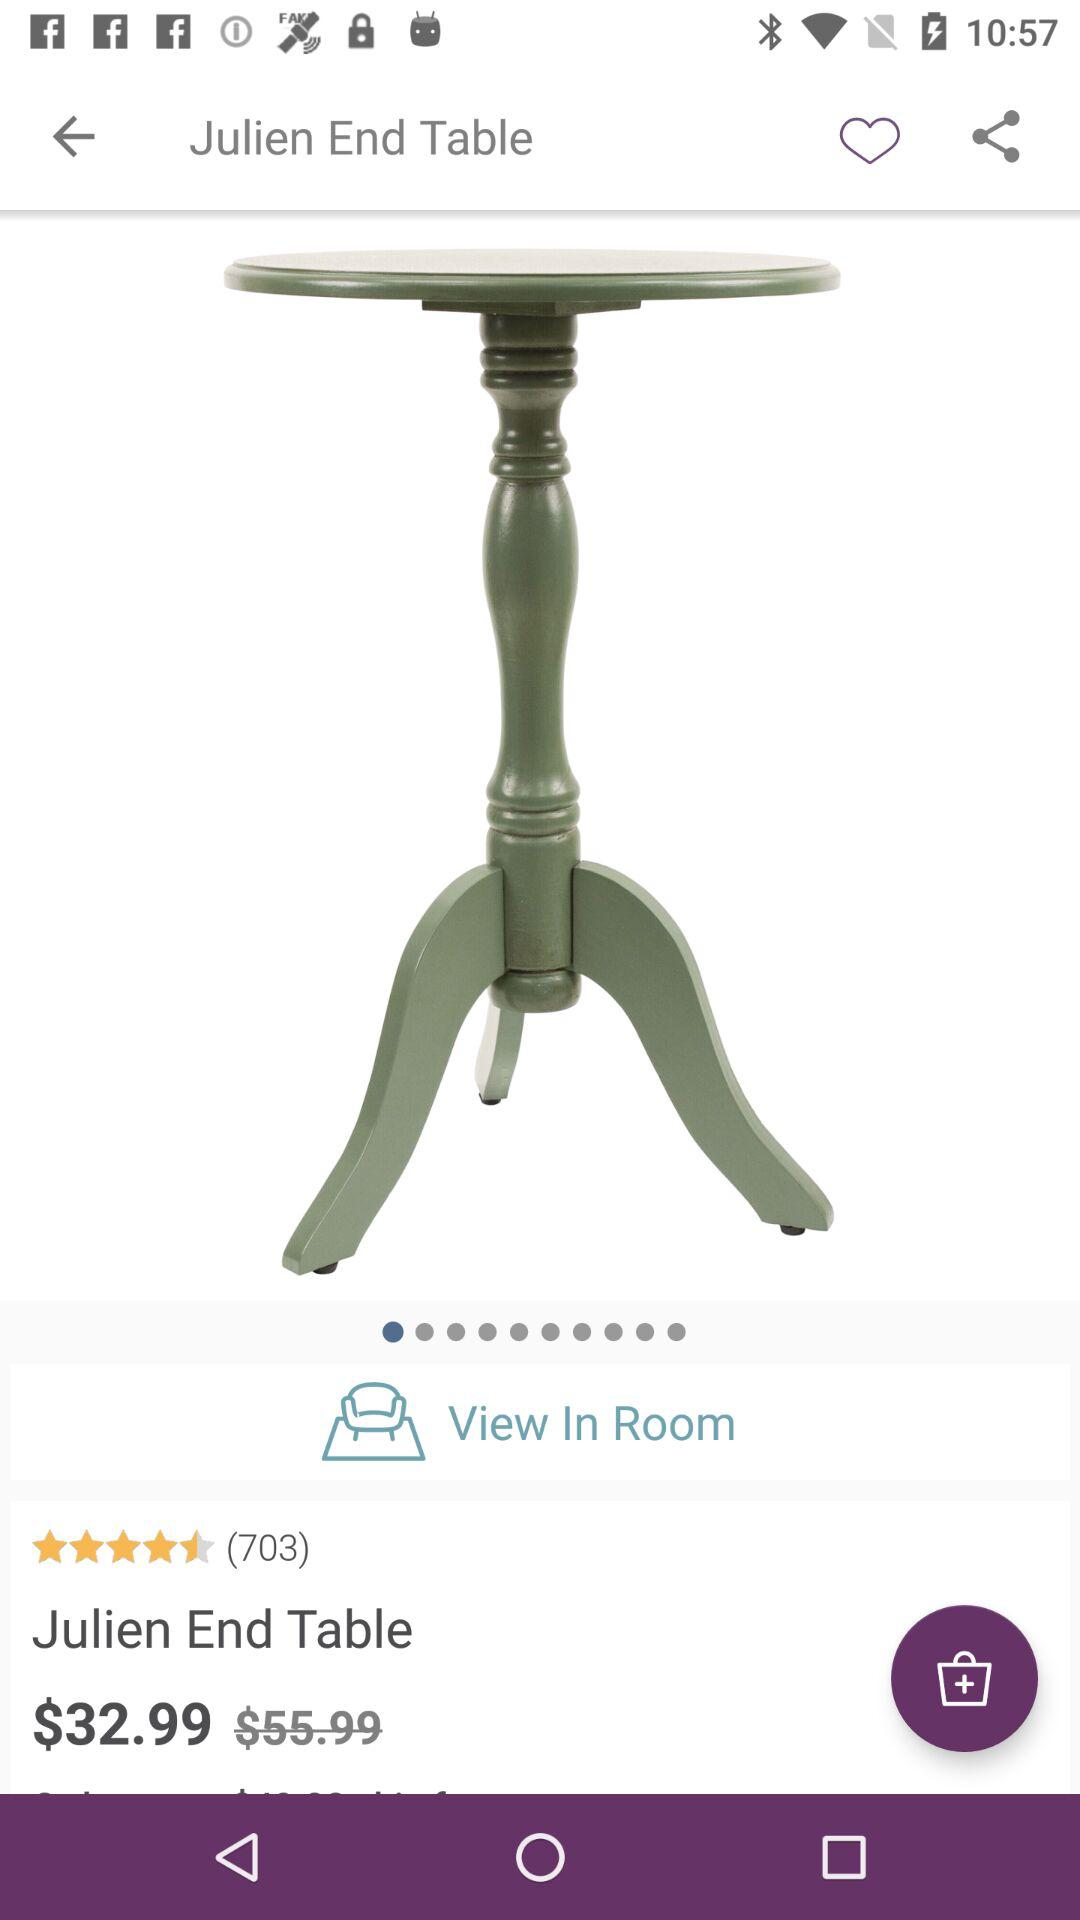How many persons are reviewed are there?
When the provided information is insufficient, respond with <no answer>. <no answer> 